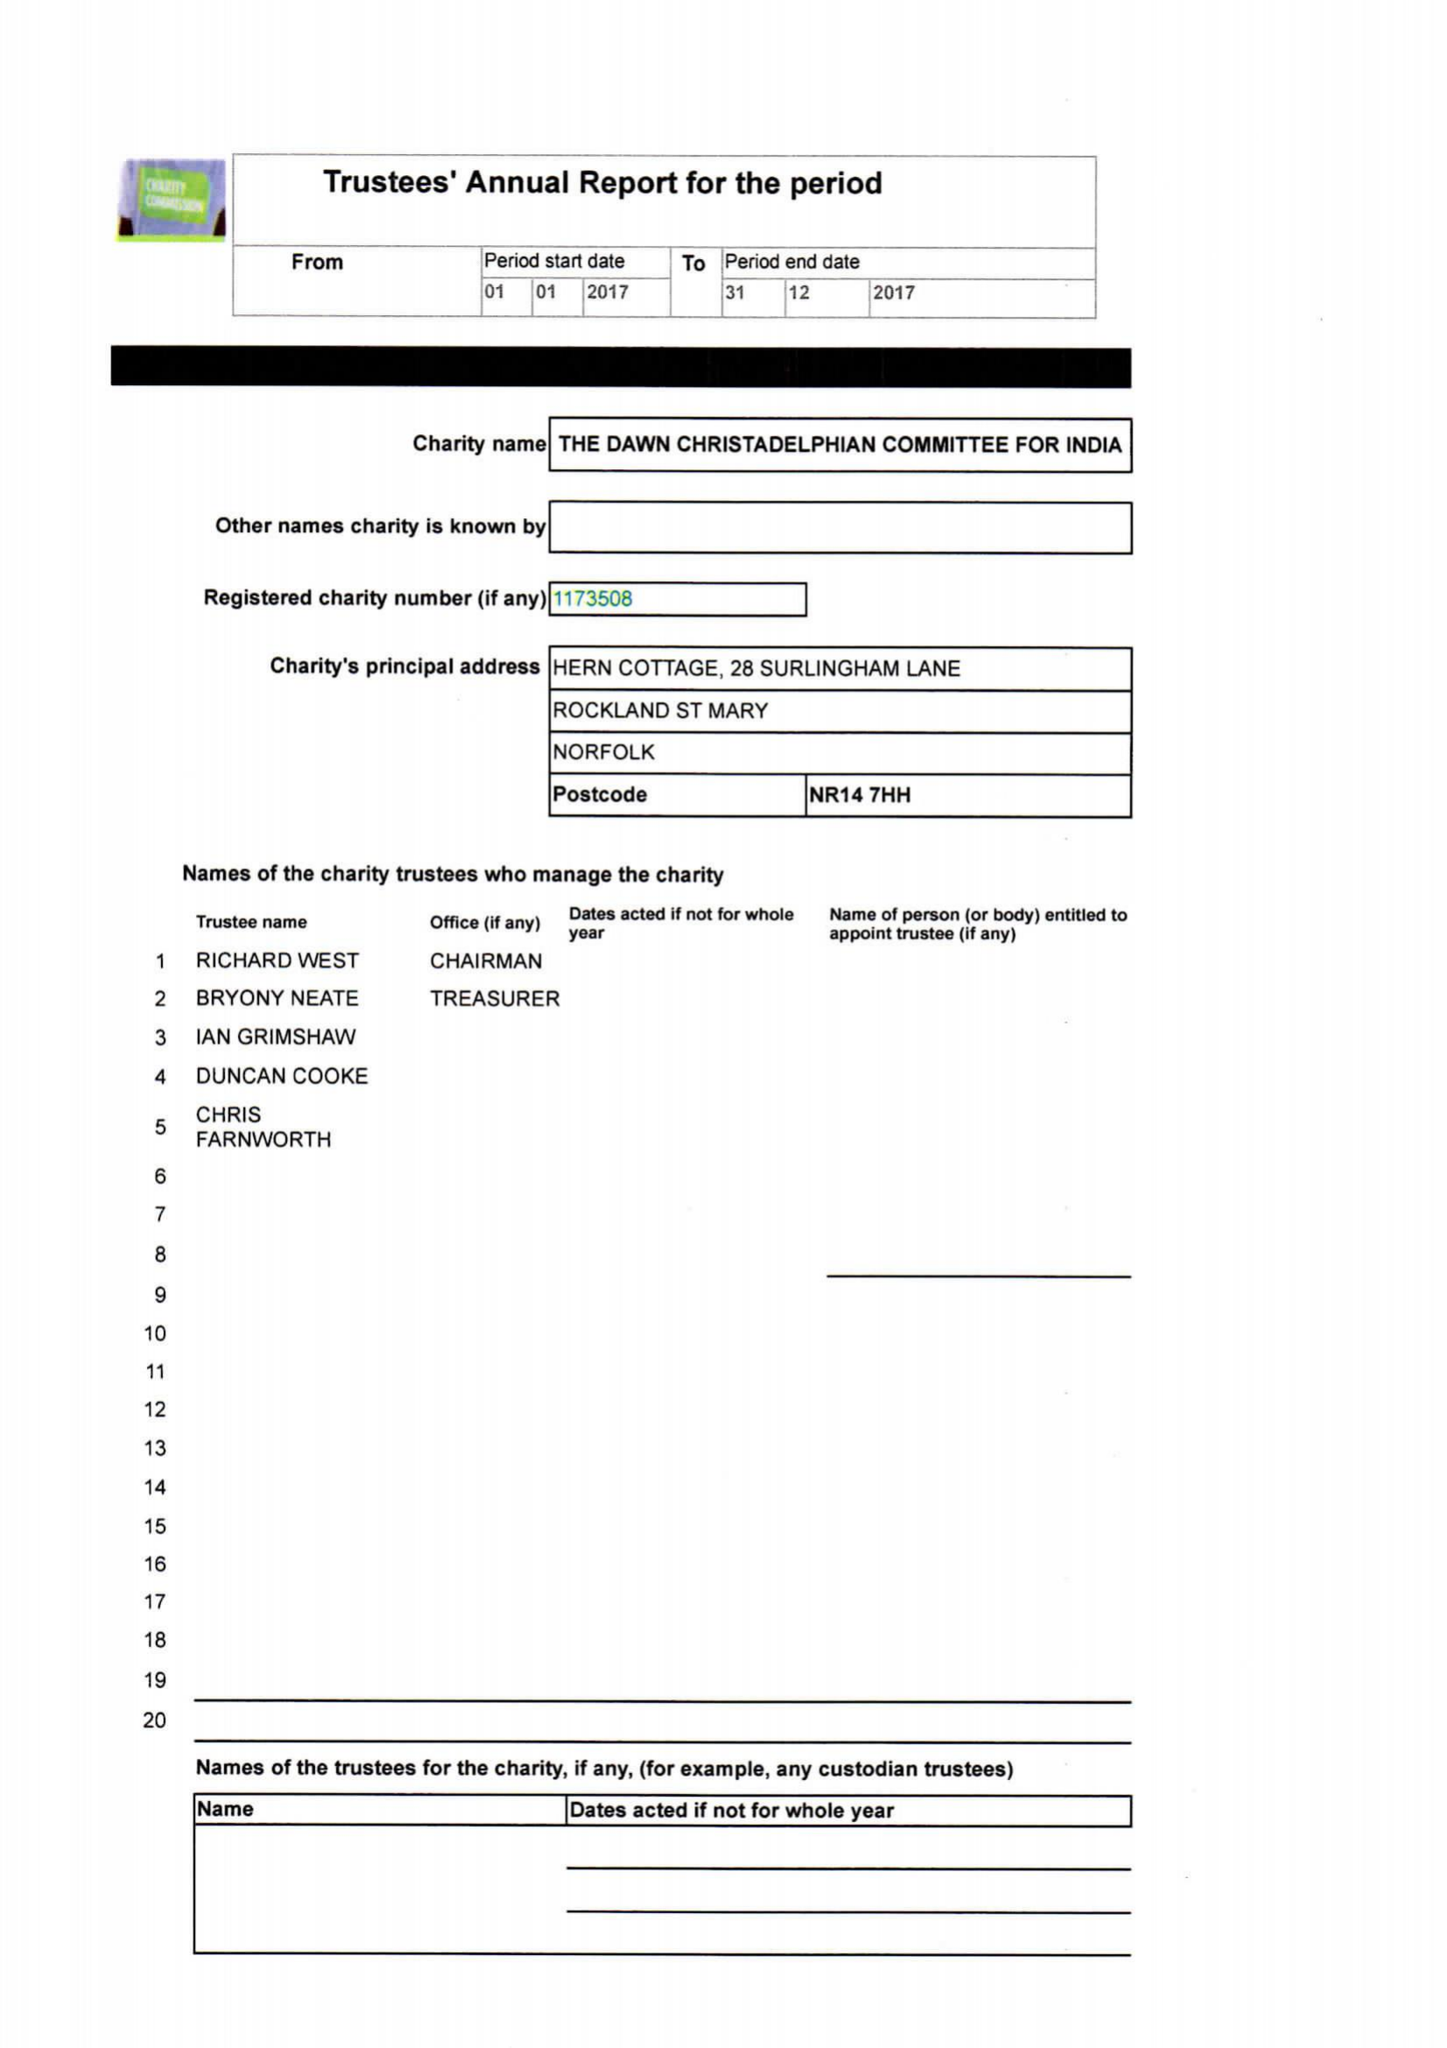What is the value for the charity_name?
Answer the question using a single word or phrase. The Dawn Christadelphian Committee For India 